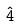Convert formula to latex. <formula><loc_0><loc_0><loc_500><loc_500>\hat { 4 }</formula> 